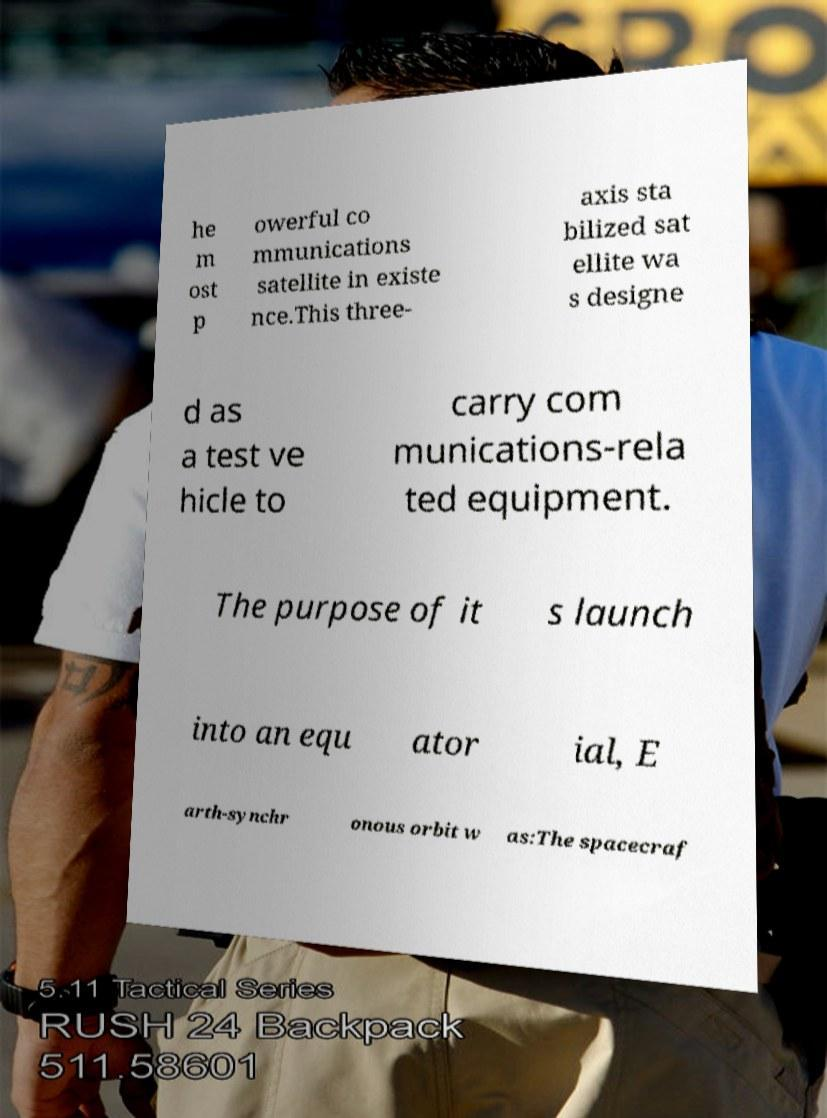Could you assist in decoding the text presented in this image and type it out clearly? he m ost p owerful co mmunications satellite in existe nce.This three- axis sta bilized sat ellite wa s designe d as a test ve hicle to carry com munications-rela ted equipment. The purpose of it s launch into an equ ator ial, E arth-synchr onous orbit w as:The spacecraf 